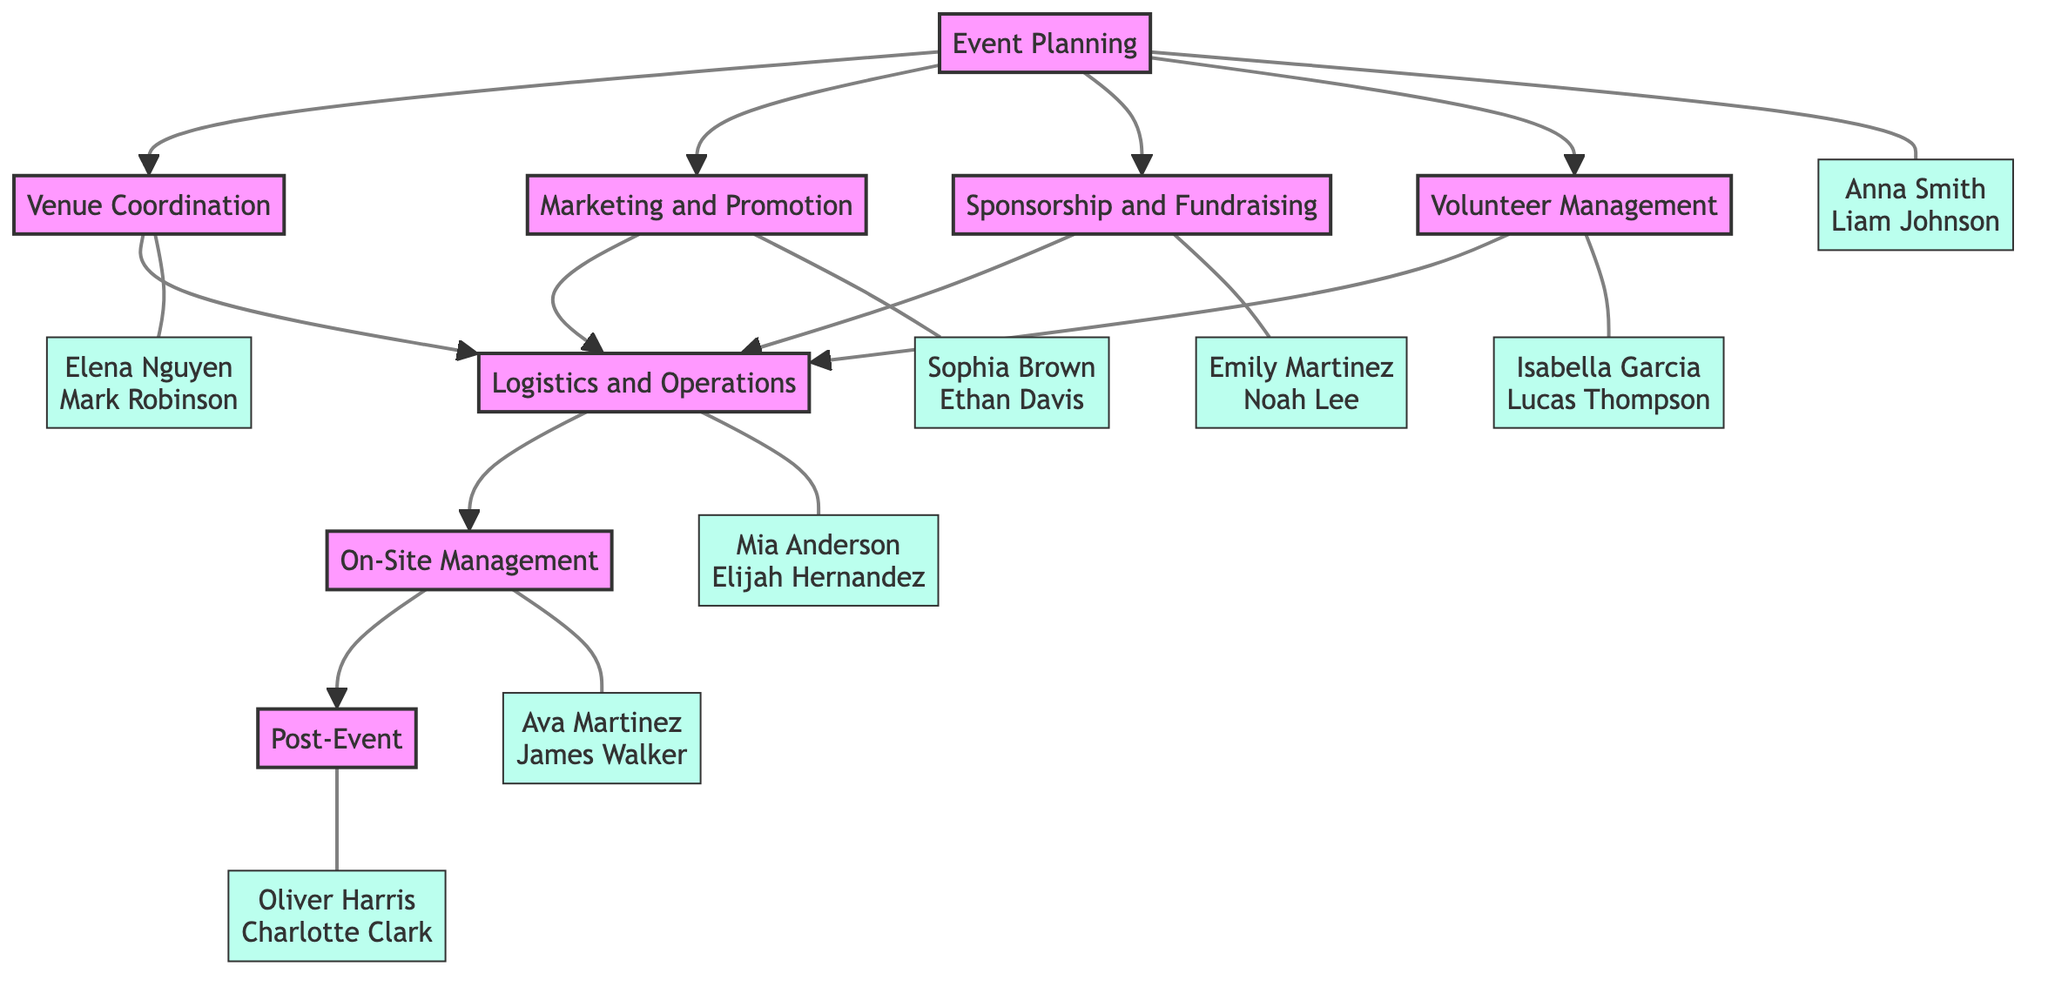What are the responsibilities of the "Event Planning" block? The "Event Planning" block lists three responsibilities: Identify event purpose, Set objectives, and Create budget. These can be found under the block labeled "Event Planning" in the diagram.
Answer: Identify event purpose, Set objectives, Create budget Who is responsible for "Venue Coordination"? The "Venue Coordination" block is assigned to two volunteers: Elena Nguyen and Mark Robinson. This information is visible under the "Venue Coordination" block in the diagram.
Answer: Elena Nguyen, Mark Robinson How many blocks are there in total? The diagram consists of eight blocks representing different stages of organizing the event. These include Event Planning, Venue Coordination, Marketing and Promotion, Sponsorship and Fundraising, Volunteer Management, Logistics and Operations, On-Site Management, and Post-Event.
Answer: Eight Which block has the most volunteers assigned to it? The "Volunteer Management" block has the most volunteers assigned, which are Isabella Garcia and Lucas Thompson, but every block has two volunteers assigned, thus they are all equal in number. However, the emphasis reflects the unique role of volunteer management.
Answer: Each block has two volunteers What follows after "Logistics and Operations" in the workflow? "On-Site Management" directly follows "Logistics and Operations" in the workflow, as indicated by the arrow connecting these two blocks in the diagram. This means that the logistics and operations are carried out before managing the event on-site.
Answer: On-Site Management Who is responsible for post-event activities? The "Post-Event" block lists two volunteers responsible for post-event activities: Oliver Harris and Charlotte Clark, as shown in the diagram beneath the "Post-Event" block.
Answer: Oliver Harris, Charlotte Clark What is the main purpose of the "Marketing and Promotion" block? The main purpose of the "Marketing and Promotion" block is to handle tasks related to promoting the event, which includes designing promotional materials, managing social media, and distributing flyers and posters. This can be deduced from the responsibilities listed under this block.
Answer: Design promotional materials, Manage social media, Distribute flyers and posters Which two blocks impact the "Logistics and Operations"? The "Logistics and Operations" block is influenced by three preceding blocks: Venue Coordination, Marketing and Promotion, and Sponsorship and Fundraising. Each of these contributes to the logistics and operations for the event, as they all point to it in the diagram.
Answer: Venue Coordination, Marketing and Promotion, Sponsorship and Fundraising 